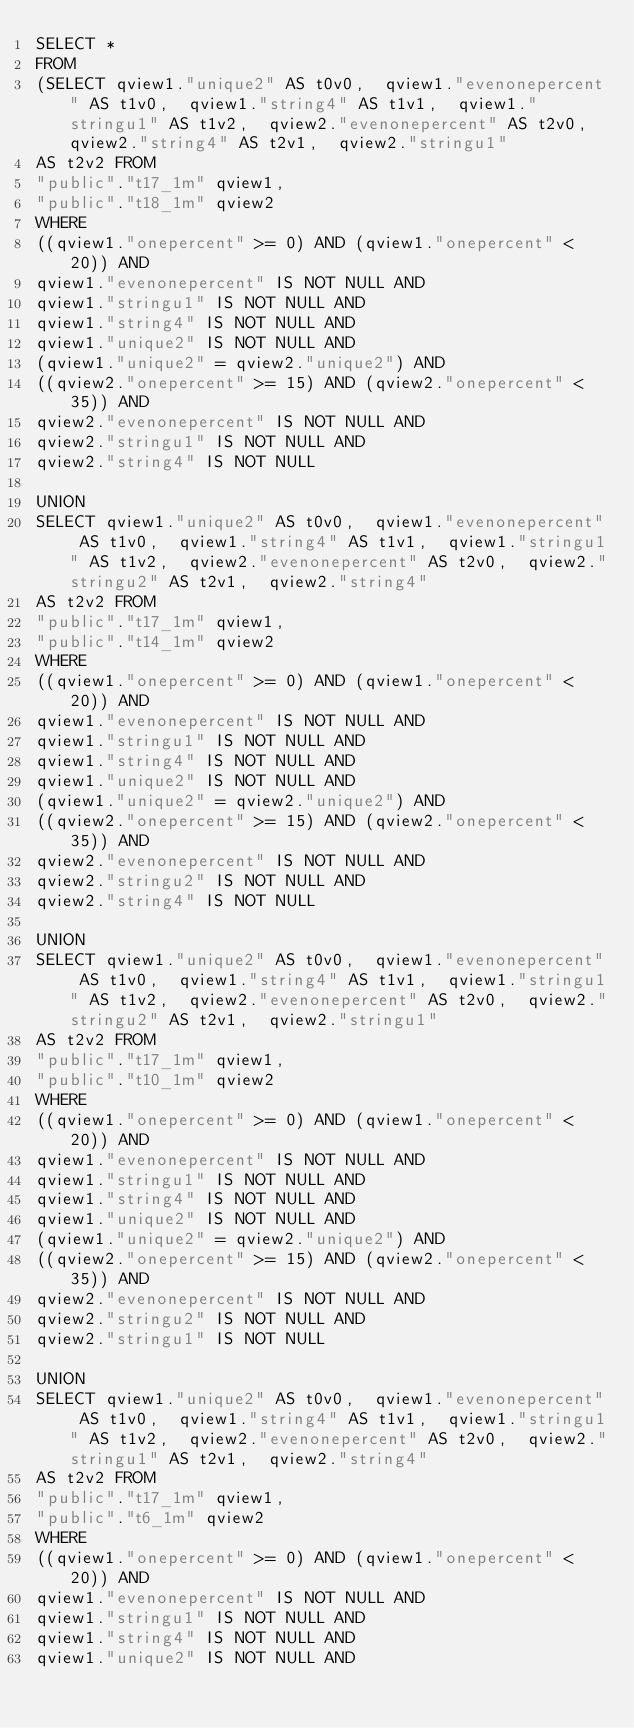<code> <loc_0><loc_0><loc_500><loc_500><_SQL_>SELECT *
FROM
(SELECT qview1."unique2" AS t0v0,  qview1."evenonepercent" AS t1v0,  qview1."string4" AS t1v1,  qview1."stringu1" AS t1v2,  qview2."evenonepercent" AS t2v0,  qview2."string4" AS t2v1,  qview2."stringu1"
AS t2v2 FROM
"public"."t17_1m" qview1,
"public"."t18_1m" qview2
WHERE
((qview1."onepercent" >= 0) AND (qview1."onepercent" < 20)) AND
qview1."evenonepercent" IS NOT NULL AND
qview1."stringu1" IS NOT NULL AND
qview1."string4" IS NOT NULL AND
qview1."unique2" IS NOT NULL AND
(qview1."unique2" = qview2."unique2") AND
((qview2."onepercent" >= 15) AND (qview2."onepercent" < 35)) AND
qview2."evenonepercent" IS NOT NULL AND
qview2."stringu1" IS NOT NULL AND
qview2."string4" IS NOT NULL

UNION
SELECT qview1."unique2" AS t0v0,  qview1."evenonepercent" AS t1v0,  qview1."string4" AS t1v1,  qview1."stringu1" AS t1v2,  qview2."evenonepercent" AS t2v0,  qview2."stringu2" AS t2v1,  qview2."string4"
AS t2v2 FROM
"public"."t17_1m" qview1,
"public"."t14_1m" qview2
WHERE
((qview1."onepercent" >= 0) AND (qview1."onepercent" < 20)) AND
qview1."evenonepercent" IS NOT NULL AND
qview1."stringu1" IS NOT NULL AND
qview1."string4" IS NOT NULL AND
qview1."unique2" IS NOT NULL AND
(qview1."unique2" = qview2."unique2") AND
((qview2."onepercent" >= 15) AND (qview2."onepercent" < 35)) AND
qview2."evenonepercent" IS NOT NULL AND
qview2."stringu2" IS NOT NULL AND
qview2."string4" IS NOT NULL

UNION
SELECT qview1."unique2" AS t0v0,  qview1."evenonepercent" AS t1v0,  qview1."string4" AS t1v1,  qview1."stringu1" AS t1v2,  qview2."evenonepercent" AS t2v0,  qview2."stringu2" AS t2v1,  qview2."stringu1"
AS t2v2 FROM
"public"."t17_1m" qview1,
"public"."t10_1m" qview2
WHERE
((qview1."onepercent" >= 0) AND (qview1."onepercent" < 20)) AND
qview1."evenonepercent" IS NOT NULL AND
qview1."stringu1" IS NOT NULL AND
qview1."string4" IS NOT NULL AND
qview1."unique2" IS NOT NULL AND
(qview1."unique2" = qview2."unique2") AND
((qview2."onepercent" >= 15) AND (qview2."onepercent" < 35)) AND
qview2."evenonepercent" IS NOT NULL AND
qview2."stringu2" IS NOT NULL AND
qview2."stringu1" IS NOT NULL

UNION
SELECT qview1."unique2" AS t0v0,  qview1."evenonepercent" AS t1v0,  qview1."string4" AS t1v1,  qview1."stringu1" AS t1v2,  qview2."evenonepercent" AS t2v0,  qview2."stringu1" AS t2v1,  qview2."string4"
AS t2v2 FROM
"public"."t17_1m" qview1,
"public"."t6_1m" qview2
WHERE
((qview1."onepercent" >= 0) AND (qview1."onepercent" < 20)) AND
qview1."evenonepercent" IS NOT NULL AND
qview1."stringu1" IS NOT NULL AND
qview1."string4" IS NOT NULL AND
qview1."unique2" IS NOT NULL AND</code> 